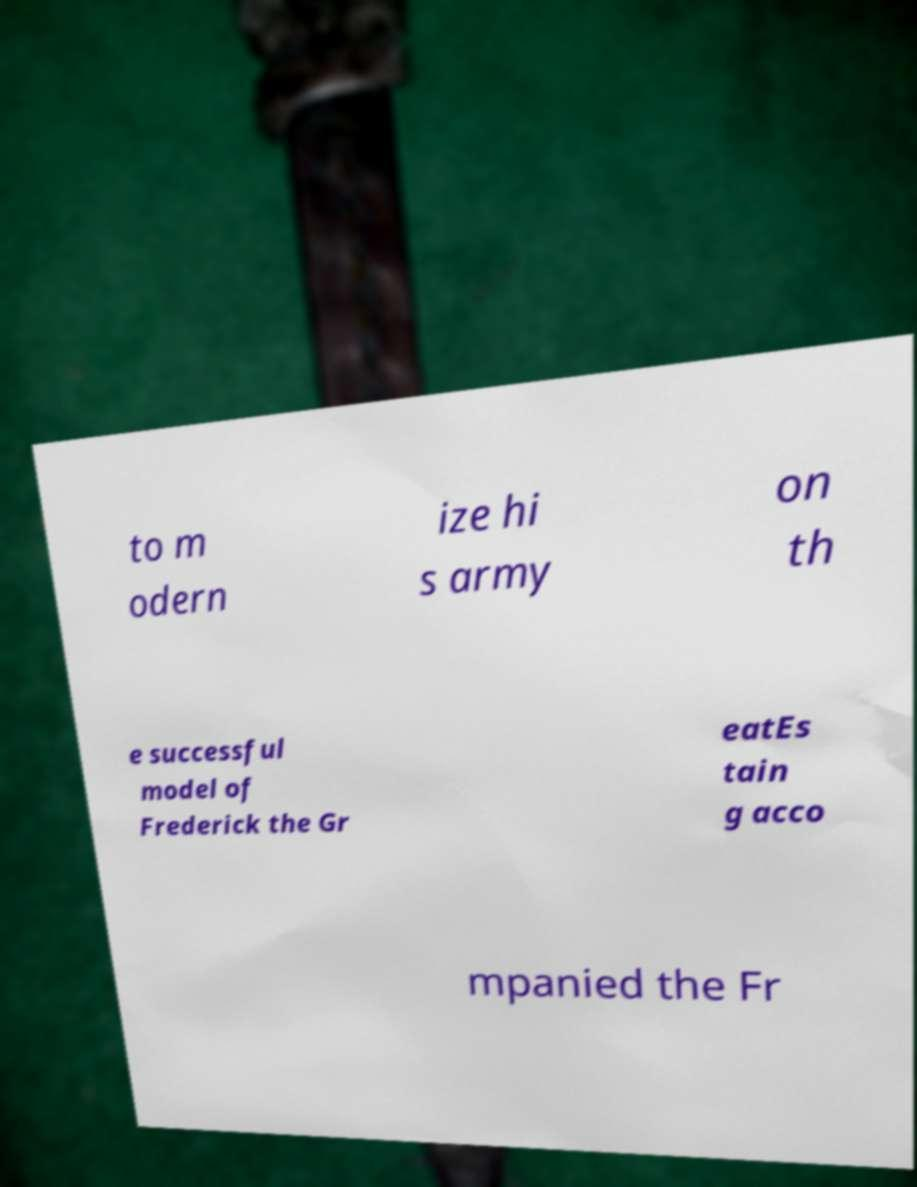Could you assist in decoding the text presented in this image and type it out clearly? to m odern ize hi s army on th e successful model of Frederick the Gr eatEs tain g acco mpanied the Fr 